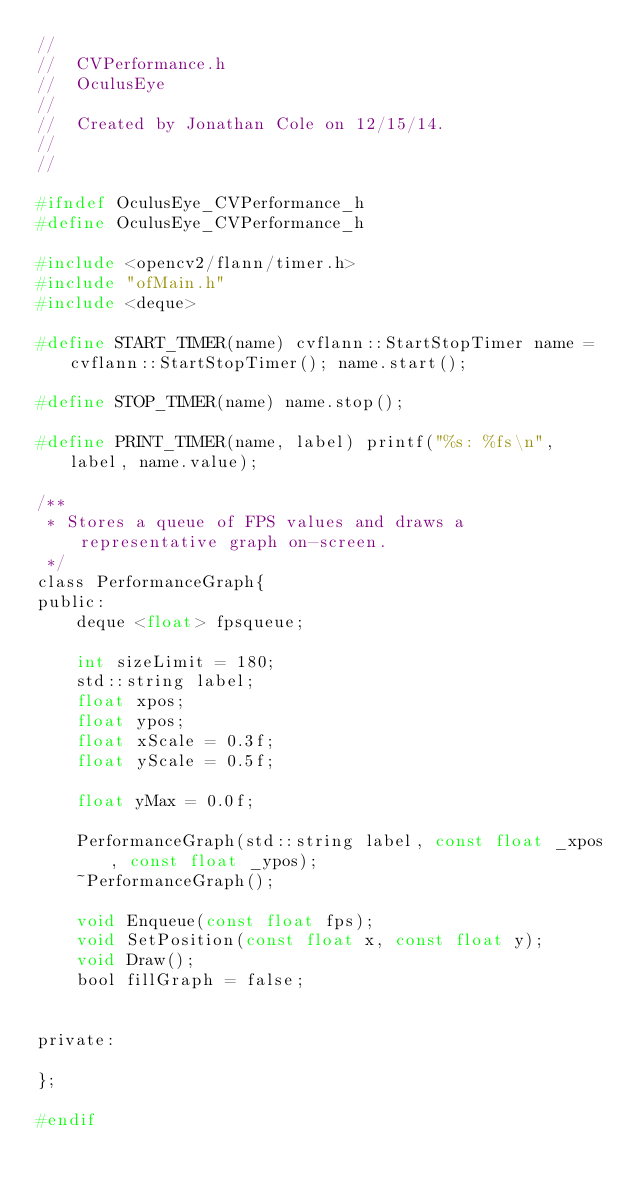Convert code to text. <code><loc_0><loc_0><loc_500><loc_500><_C_>//
//  CVPerformance.h
//  OculusEye
//
//  Created by Jonathan Cole on 12/15/14.
//
//

#ifndef OculusEye_CVPerformance_h
#define OculusEye_CVPerformance_h

#include <opencv2/flann/timer.h>
#include "ofMain.h"
#include <deque>

#define START_TIMER(name) cvflann::StartStopTimer name = cvflann::StartStopTimer(); name.start();

#define STOP_TIMER(name) name.stop();

#define PRINT_TIMER(name, label) printf("%s: %fs\n", label, name.value);

/**
 * Stores a queue of FPS values and draws a representative graph on-screen.
 */
class PerformanceGraph{
public:
    deque <float> fpsqueue;
    
    int sizeLimit = 180;
    std::string label;
    float xpos;
    float ypos;
    float xScale = 0.3f;
    float yScale = 0.5f;
    
    float yMax = 0.0f;
    
    PerformanceGraph(std::string label, const float _xpos, const float _ypos);
    ~PerformanceGraph();
    
    void Enqueue(const float fps);
    void SetPosition(const float x, const float y);
    void Draw();
    bool fillGraph = false;
    
    
private:
    
};

#endif</code> 